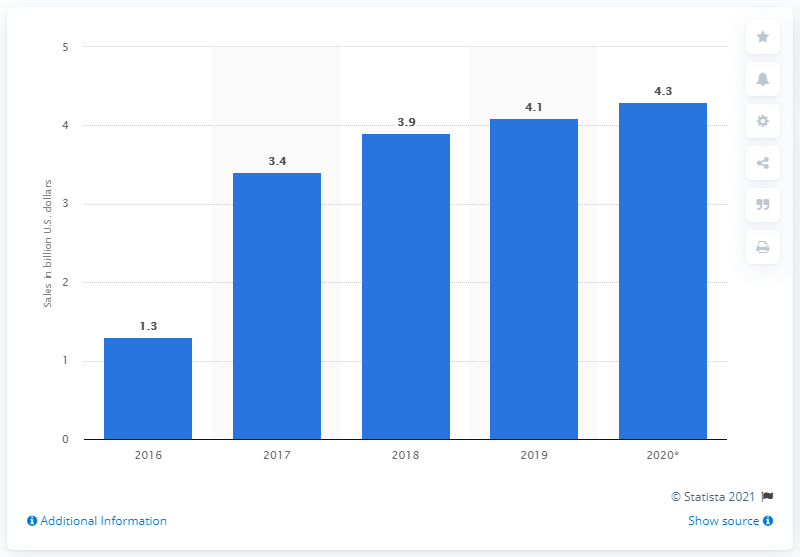Identify some key points in this picture. The projected amount of smart home sales in the United States is expected to reach 4.3 billion in 2020. 